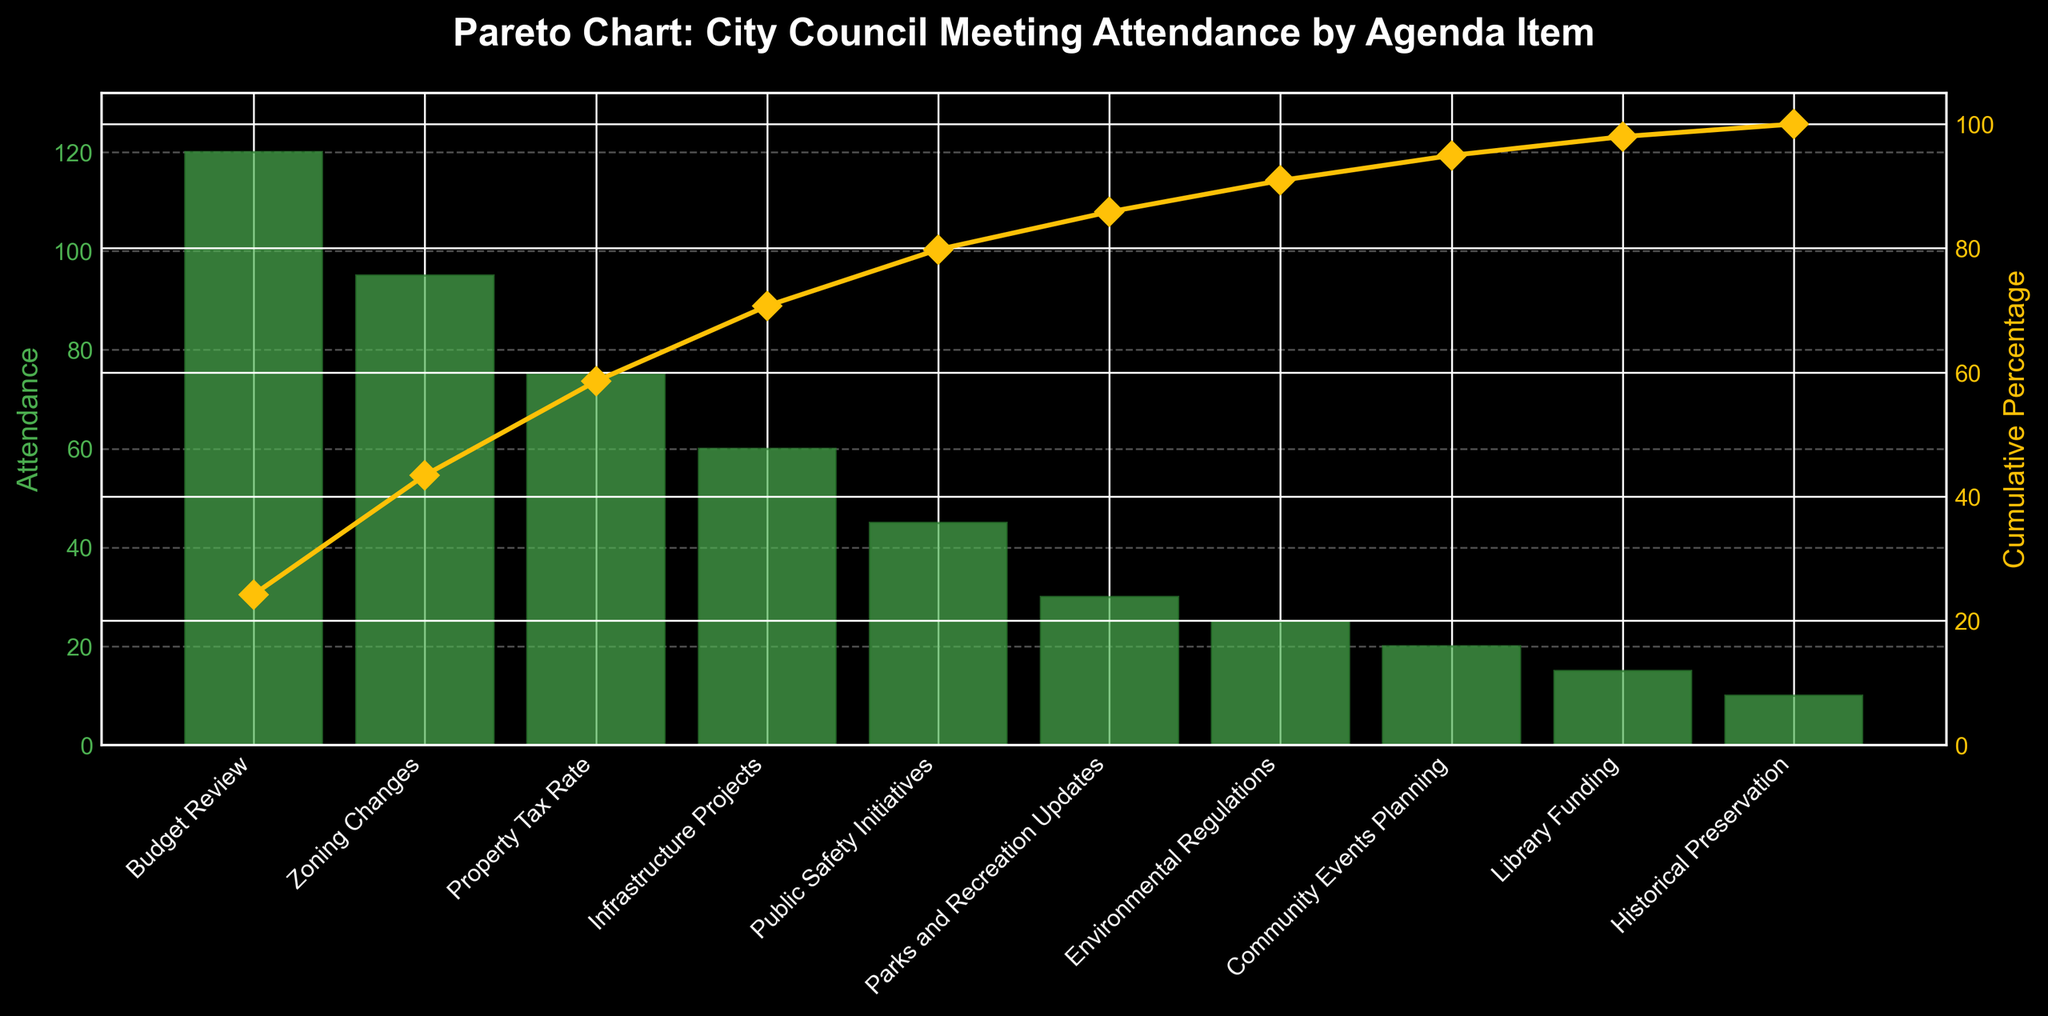How many agenda items have attendance greater than 50? By looking at the bars representing attendance figures, identify which items have attendance above 50. Only Budget Review, Zoning Changes, Property Tax Rate, and Infrastructure Projects fit this criteria.
Answer: 4 Which agenda item has the lowest attendance? Identify the shortest bar in the bar chart. Historical Preservation has the smallest bar, indicating the lowest attendance.
Answer: Historical Preservation What is the cumulative percentage for the first four agenda items? Sum the cumulative percentages for Budget Review, Zoning Changes, Property Tax Rate, and Infrastructure Projects from the corresponding line plot data points. Their cumulative percentages are 30.12, 54.82, 73.49, and 88.55 respectively.
Answer: 88.55% Compare the attendance of Zoning Changes and Property Tax Rate. Which has more attendees? Identify and compare the bar heights for Zoning Changes and Property Tax Rate. Zoning Changes has a higher bar than Property Tax Rate, indicating more attendance.
Answer: Zoning Changes What's the attendance difference between Budget Review and Library Funding? Find the heights of the bars for Budget Review and Library Funding, then calculate the difference: 120 (Budget Review) - 15 (Library Funding) = 105.
Answer: 105 What are the axis labels for the bar chart? The labels on the horizontal axis represent the different Agenda Items, while the vertical axis is labeled Attendance.
Answer: Agenda Items, Attendance At what cumulative percentage does Infrastructure Projects appear? Locate the data point for Infrastructure Projects on the cumulative percentage line, where it corresponds to approximately 88.55%.
Answer: 88.55% Which agenda items cumulatively account for over 50% of the attendance? Identify the agenda items contributing to the cumulative percentage line that passes 50%; they are Budget Review and Zoning Changes.
Answer: Budget Review, Zoning Changes What colors are used for the bars and the cumulative percentage line in the chart? The bars are colored green, and the cumulative percentage line is yellow.
Answer: Green, Yellow What is the title of the chart? The title is at the top of the figure and reads "Pareto Chart: City Council Meeting Attendance by Agenda Item".
Answer: Pareto Chart: City Council Meeting Attendance by Agenda Item 